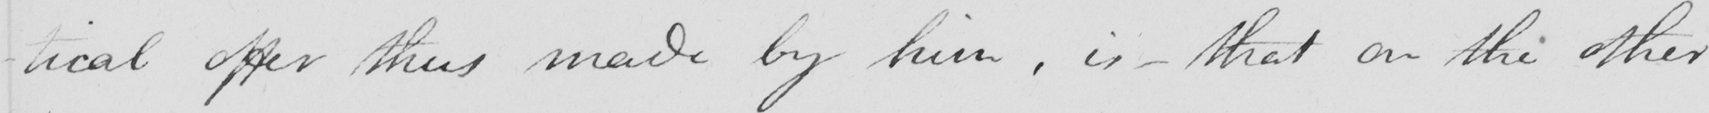What text is written in this handwritten line? -tical offer thus made by him , is  _  that on the other 